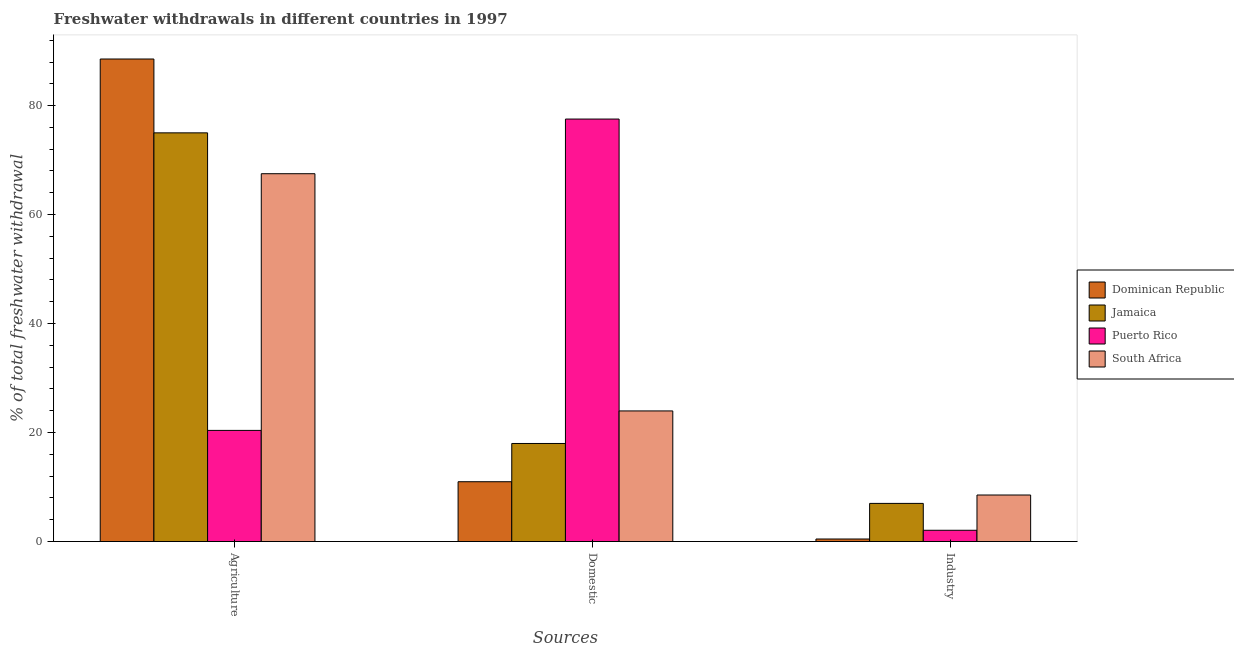How many groups of bars are there?
Provide a short and direct response. 3. Are the number of bars per tick equal to the number of legend labels?
Provide a short and direct response. Yes. How many bars are there on the 1st tick from the right?
Give a very brief answer. 4. What is the label of the 3rd group of bars from the left?
Offer a very short reply. Industry. What is the percentage of freshwater withdrawal for industry in Jamaica?
Provide a succinct answer. 7. Across all countries, what is the maximum percentage of freshwater withdrawal for agriculture?
Your answer should be compact. 88.55. Across all countries, what is the minimum percentage of freshwater withdrawal for domestic purposes?
Provide a short and direct response. 10.98. In which country was the percentage of freshwater withdrawal for domestic purposes maximum?
Offer a terse response. Puerto Rico. In which country was the percentage of freshwater withdrawal for industry minimum?
Provide a short and direct response. Dominican Republic. What is the total percentage of freshwater withdrawal for agriculture in the graph?
Offer a terse response. 251.45. What is the difference between the percentage of freshwater withdrawal for industry in Puerto Rico and that in Jamaica?
Your response must be concise. -4.93. What is the difference between the percentage of freshwater withdrawal for agriculture in Jamaica and the percentage of freshwater withdrawal for industry in South Africa?
Make the answer very short. 66.46. What is the average percentage of freshwater withdrawal for agriculture per country?
Provide a short and direct response. 62.86. What is the difference between the percentage of freshwater withdrawal for industry and percentage of freshwater withdrawal for agriculture in Puerto Rico?
Offer a terse response. -18.33. In how many countries, is the percentage of freshwater withdrawal for agriculture greater than 8 %?
Provide a short and direct response. 4. What is the ratio of the percentage of freshwater withdrawal for agriculture in Jamaica to that in South Africa?
Offer a very short reply. 1.11. Is the percentage of freshwater withdrawal for agriculture in Dominican Republic less than that in Puerto Rico?
Offer a terse response. No. Is the difference between the percentage of freshwater withdrawal for domestic purposes in Jamaica and Puerto Rico greater than the difference between the percentage of freshwater withdrawal for agriculture in Jamaica and Puerto Rico?
Give a very brief answer. No. What is the difference between the highest and the second highest percentage of freshwater withdrawal for industry?
Provide a short and direct response. 1.54. What is the difference between the highest and the lowest percentage of freshwater withdrawal for industry?
Your response must be concise. 8.08. In how many countries, is the percentage of freshwater withdrawal for domestic purposes greater than the average percentage of freshwater withdrawal for domestic purposes taken over all countries?
Make the answer very short. 1. Is the sum of the percentage of freshwater withdrawal for agriculture in Jamaica and South Africa greater than the maximum percentage of freshwater withdrawal for industry across all countries?
Your answer should be compact. Yes. What does the 2nd bar from the left in Agriculture represents?
Your answer should be compact. Jamaica. What does the 2nd bar from the right in Domestic represents?
Make the answer very short. Puerto Rico. How many bars are there?
Make the answer very short. 12. Are all the bars in the graph horizontal?
Offer a terse response. No. How many countries are there in the graph?
Your answer should be compact. 4. Are the values on the major ticks of Y-axis written in scientific E-notation?
Your answer should be compact. No. Does the graph contain any zero values?
Offer a very short reply. No. Does the graph contain grids?
Give a very brief answer. No. Where does the legend appear in the graph?
Make the answer very short. Center right. How are the legend labels stacked?
Your response must be concise. Vertical. What is the title of the graph?
Your response must be concise. Freshwater withdrawals in different countries in 1997. Does "Solomon Islands" appear as one of the legend labels in the graph?
Provide a short and direct response. No. What is the label or title of the X-axis?
Provide a succinct answer. Sources. What is the label or title of the Y-axis?
Offer a terse response. % of total freshwater withdrawal. What is the % of total freshwater withdrawal in Dominican Republic in Agriculture?
Your answer should be compact. 88.55. What is the % of total freshwater withdrawal of Puerto Rico in Agriculture?
Offer a very short reply. 20.4. What is the % of total freshwater withdrawal of South Africa in Agriculture?
Your response must be concise. 67.5. What is the % of total freshwater withdrawal of Dominican Republic in Domestic?
Ensure brevity in your answer.  10.98. What is the % of total freshwater withdrawal in Jamaica in Domestic?
Keep it short and to the point. 18. What is the % of total freshwater withdrawal of Puerto Rico in Domestic?
Your answer should be very brief. 77.53. What is the % of total freshwater withdrawal in South Africa in Domestic?
Ensure brevity in your answer.  23.97. What is the % of total freshwater withdrawal in Dominican Republic in Industry?
Your answer should be compact. 0.47. What is the % of total freshwater withdrawal in Jamaica in Industry?
Keep it short and to the point. 7. What is the % of total freshwater withdrawal in Puerto Rico in Industry?
Provide a succinct answer. 2.07. What is the % of total freshwater withdrawal in South Africa in Industry?
Your answer should be very brief. 8.54. Across all Sources, what is the maximum % of total freshwater withdrawal of Dominican Republic?
Provide a short and direct response. 88.55. Across all Sources, what is the maximum % of total freshwater withdrawal of Jamaica?
Give a very brief answer. 75. Across all Sources, what is the maximum % of total freshwater withdrawal of Puerto Rico?
Provide a succinct answer. 77.53. Across all Sources, what is the maximum % of total freshwater withdrawal in South Africa?
Make the answer very short. 67.5. Across all Sources, what is the minimum % of total freshwater withdrawal of Dominican Republic?
Keep it short and to the point. 0.47. Across all Sources, what is the minimum % of total freshwater withdrawal of Jamaica?
Provide a succinct answer. 7. Across all Sources, what is the minimum % of total freshwater withdrawal in Puerto Rico?
Keep it short and to the point. 2.07. Across all Sources, what is the minimum % of total freshwater withdrawal in South Africa?
Offer a terse response. 8.54. What is the total % of total freshwater withdrawal in Dominican Republic in the graph?
Make the answer very short. 100. What is the total % of total freshwater withdrawal of Jamaica in the graph?
Make the answer very short. 100. What is the total % of total freshwater withdrawal of Puerto Rico in the graph?
Your answer should be very brief. 100. What is the total % of total freshwater withdrawal of South Africa in the graph?
Your response must be concise. 100.01. What is the difference between the % of total freshwater withdrawal of Dominican Republic in Agriculture and that in Domestic?
Ensure brevity in your answer.  77.57. What is the difference between the % of total freshwater withdrawal of Puerto Rico in Agriculture and that in Domestic?
Give a very brief answer. -57.13. What is the difference between the % of total freshwater withdrawal in South Africa in Agriculture and that in Domestic?
Provide a short and direct response. 43.53. What is the difference between the % of total freshwater withdrawal in Dominican Republic in Agriculture and that in Industry?
Ensure brevity in your answer.  88.08. What is the difference between the % of total freshwater withdrawal in Jamaica in Agriculture and that in Industry?
Your answer should be very brief. 68. What is the difference between the % of total freshwater withdrawal in Puerto Rico in Agriculture and that in Industry?
Your response must be concise. 18.33. What is the difference between the % of total freshwater withdrawal of South Africa in Agriculture and that in Industry?
Your answer should be compact. 58.96. What is the difference between the % of total freshwater withdrawal of Dominican Republic in Domestic and that in Industry?
Keep it short and to the point. 10.51. What is the difference between the % of total freshwater withdrawal in Jamaica in Domestic and that in Industry?
Give a very brief answer. 11. What is the difference between the % of total freshwater withdrawal of Puerto Rico in Domestic and that in Industry?
Ensure brevity in your answer.  75.46. What is the difference between the % of total freshwater withdrawal of South Africa in Domestic and that in Industry?
Make the answer very short. 15.43. What is the difference between the % of total freshwater withdrawal in Dominican Republic in Agriculture and the % of total freshwater withdrawal in Jamaica in Domestic?
Keep it short and to the point. 70.55. What is the difference between the % of total freshwater withdrawal in Dominican Republic in Agriculture and the % of total freshwater withdrawal in Puerto Rico in Domestic?
Ensure brevity in your answer.  11.02. What is the difference between the % of total freshwater withdrawal in Dominican Republic in Agriculture and the % of total freshwater withdrawal in South Africa in Domestic?
Offer a terse response. 64.58. What is the difference between the % of total freshwater withdrawal of Jamaica in Agriculture and the % of total freshwater withdrawal of Puerto Rico in Domestic?
Keep it short and to the point. -2.53. What is the difference between the % of total freshwater withdrawal of Jamaica in Agriculture and the % of total freshwater withdrawal of South Africa in Domestic?
Keep it short and to the point. 51.03. What is the difference between the % of total freshwater withdrawal of Puerto Rico in Agriculture and the % of total freshwater withdrawal of South Africa in Domestic?
Offer a terse response. -3.57. What is the difference between the % of total freshwater withdrawal in Dominican Republic in Agriculture and the % of total freshwater withdrawal in Jamaica in Industry?
Make the answer very short. 81.55. What is the difference between the % of total freshwater withdrawal of Dominican Republic in Agriculture and the % of total freshwater withdrawal of Puerto Rico in Industry?
Provide a succinct answer. 86.48. What is the difference between the % of total freshwater withdrawal of Dominican Republic in Agriculture and the % of total freshwater withdrawal of South Africa in Industry?
Provide a succinct answer. 80.01. What is the difference between the % of total freshwater withdrawal of Jamaica in Agriculture and the % of total freshwater withdrawal of Puerto Rico in Industry?
Keep it short and to the point. 72.93. What is the difference between the % of total freshwater withdrawal in Jamaica in Agriculture and the % of total freshwater withdrawal in South Africa in Industry?
Give a very brief answer. 66.46. What is the difference between the % of total freshwater withdrawal in Puerto Rico in Agriculture and the % of total freshwater withdrawal in South Africa in Industry?
Give a very brief answer. 11.86. What is the difference between the % of total freshwater withdrawal in Dominican Republic in Domestic and the % of total freshwater withdrawal in Jamaica in Industry?
Your answer should be very brief. 3.98. What is the difference between the % of total freshwater withdrawal of Dominican Republic in Domestic and the % of total freshwater withdrawal of Puerto Rico in Industry?
Ensure brevity in your answer.  8.91. What is the difference between the % of total freshwater withdrawal in Dominican Republic in Domestic and the % of total freshwater withdrawal in South Africa in Industry?
Offer a terse response. 2.44. What is the difference between the % of total freshwater withdrawal in Jamaica in Domestic and the % of total freshwater withdrawal in Puerto Rico in Industry?
Offer a very short reply. 15.93. What is the difference between the % of total freshwater withdrawal in Jamaica in Domestic and the % of total freshwater withdrawal in South Africa in Industry?
Provide a short and direct response. 9.46. What is the difference between the % of total freshwater withdrawal of Puerto Rico in Domestic and the % of total freshwater withdrawal of South Africa in Industry?
Offer a terse response. 68.99. What is the average % of total freshwater withdrawal of Dominican Republic per Sources?
Give a very brief answer. 33.33. What is the average % of total freshwater withdrawal in Jamaica per Sources?
Your answer should be compact. 33.33. What is the average % of total freshwater withdrawal in Puerto Rico per Sources?
Your answer should be compact. 33.33. What is the average % of total freshwater withdrawal of South Africa per Sources?
Your answer should be very brief. 33.34. What is the difference between the % of total freshwater withdrawal of Dominican Republic and % of total freshwater withdrawal of Jamaica in Agriculture?
Keep it short and to the point. 13.55. What is the difference between the % of total freshwater withdrawal in Dominican Republic and % of total freshwater withdrawal in Puerto Rico in Agriculture?
Ensure brevity in your answer.  68.15. What is the difference between the % of total freshwater withdrawal in Dominican Republic and % of total freshwater withdrawal in South Africa in Agriculture?
Your answer should be compact. 21.05. What is the difference between the % of total freshwater withdrawal of Jamaica and % of total freshwater withdrawal of Puerto Rico in Agriculture?
Your answer should be compact. 54.6. What is the difference between the % of total freshwater withdrawal of Jamaica and % of total freshwater withdrawal of South Africa in Agriculture?
Offer a terse response. 7.5. What is the difference between the % of total freshwater withdrawal in Puerto Rico and % of total freshwater withdrawal in South Africa in Agriculture?
Keep it short and to the point. -47.1. What is the difference between the % of total freshwater withdrawal of Dominican Republic and % of total freshwater withdrawal of Jamaica in Domestic?
Ensure brevity in your answer.  -7.02. What is the difference between the % of total freshwater withdrawal in Dominican Republic and % of total freshwater withdrawal in Puerto Rico in Domestic?
Keep it short and to the point. -66.55. What is the difference between the % of total freshwater withdrawal in Dominican Republic and % of total freshwater withdrawal in South Africa in Domestic?
Your response must be concise. -12.99. What is the difference between the % of total freshwater withdrawal in Jamaica and % of total freshwater withdrawal in Puerto Rico in Domestic?
Make the answer very short. -59.53. What is the difference between the % of total freshwater withdrawal of Jamaica and % of total freshwater withdrawal of South Africa in Domestic?
Offer a very short reply. -5.97. What is the difference between the % of total freshwater withdrawal of Puerto Rico and % of total freshwater withdrawal of South Africa in Domestic?
Provide a succinct answer. 53.56. What is the difference between the % of total freshwater withdrawal of Dominican Republic and % of total freshwater withdrawal of Jamaica in Industry?
Offer a terse response. -6.54. What is the difference between the % of total freshwater withdrawal in Dominican Republic and % of total freshwater withdrawal in Puerto Rico in Industry?
Keep it short and to the point. -1.6. What is the difference between the % of total freshwater withdrawal in Dominican Republic and % of total freshwater withdrawal in South Africa in Industry?
Offer a very short reply. -8.08. What is the difference between the % of total freshwater withdrawal of Jamaica and % of total freshwater withdrawal of Puerto Rico in Industry?
Give a very brief answer. 4.93. What is the difference between the % of total freshwater withdrawal in Jamaica and % of total freshwater withdrawal in South Africa in Industry?
Provide a succinct answer. -1.54. What is the difference between the % of total freshwater withdrawal of Puerto Rico and % of total freshwater withdrawal of South Africa in Industry?
Offer a terse response. -6.47. What is the ratio of the % of total freshwater withdrawal in Dominican Republic in Agriculture to that in Domestic?
Your response must be concise. 8.06. What is the ratio of the % of total freshwater withdrawal of Jamaica in Agriculture to that in Domestic?
Make the answer very short. 4.17. What is the ratio of the % of total freshwater withdrawal in Puerto Rico in Agriculture to that in Domestic?
Keep it short and to the point. 0.26. What is the ratio of the % of total freshwater withdrawal in South Africa in Agriculture to that in Domestic?
Provide a short and direct response. 2.82. What is the ratio of the % of total freshwater withdrawal of Dominican Republic in Agriculture to that in Industry?
Provide a short and direct response. 189.33. What is the ratio of the % of total freshwater withdrawal of Jamaica in Agriculture to that in Industry?
Ensure brevity in your answer.  10.71. What is the ratio of the % of total freshwater withdrawal of Puerto Rico in Agriculture to that in Industry?
Ensure brevity in your answer.  9.85. What is the ratio of the % of total freshwater withdrawal in South Africa in Agriculture to that in Industry?
Provide a succinct answer. 7.9. What is the ratio of the % of total freshwater withdrawal in Dominican Republic in Domestic to that in Industry?
Give a very brief answer. 23.48. What is the ratio of the % of total freshwater withdrawal of Jamaica in Domestic to that in Industry?
Keep it short and to the point. 2.57. What is the ratio of the % of total freshwater withdrawal in Puerto Rico in Domestic to that in Industry?
Keep it short and to the point. 37.42. What is the ratio of the % of total freshwater withdrawal in South Africa in Domestic to that in Industry?
Provide a short and direct response. 2.81. What is the difference between the highest and the second highest % of total freshwater withdrawal of Dominican Republic?
Your answer should be very brief. 77.57. What is the difference between the highest and the second highest % of total freshwater withdrawal in Puerto Rico?
Your answer should be compact. 57.13. What is the difference between the highest and the second highest % of total freshwater withdrawal in South Africa?
Ensure brevity in your answer.  43.53. What is the difference between the highest and the lowest % of total freshwater withdrawal of Dominican Republic?
Keep it short and to the point. 88.08. What is the difference between the highest and the lowest % of total freshwater withdrawal in Jamaica?
Provide a short and direct response. 68. What is the difference between the highest and the lowest % of total freshwater withdrawal in Puerto Rico?
Your response must be concise. 75.46. What is the difference between the highest and the lowest % of total freshwater withdrawal in South Africa?
Offer a terse response. 58.96. 